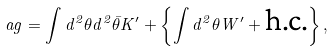Convert formula to latex. <formula><loc_0><loc_0><loc_500><loc_500>\L a g = \int d ^ { 2 } \theta d ^ { 2 } \bar { \theta } K ^ { \prime } + \left \{ \int d ^ { 2 } \theta W ^ { \prime } + \text {h.c.} \right \} ,</formula> 